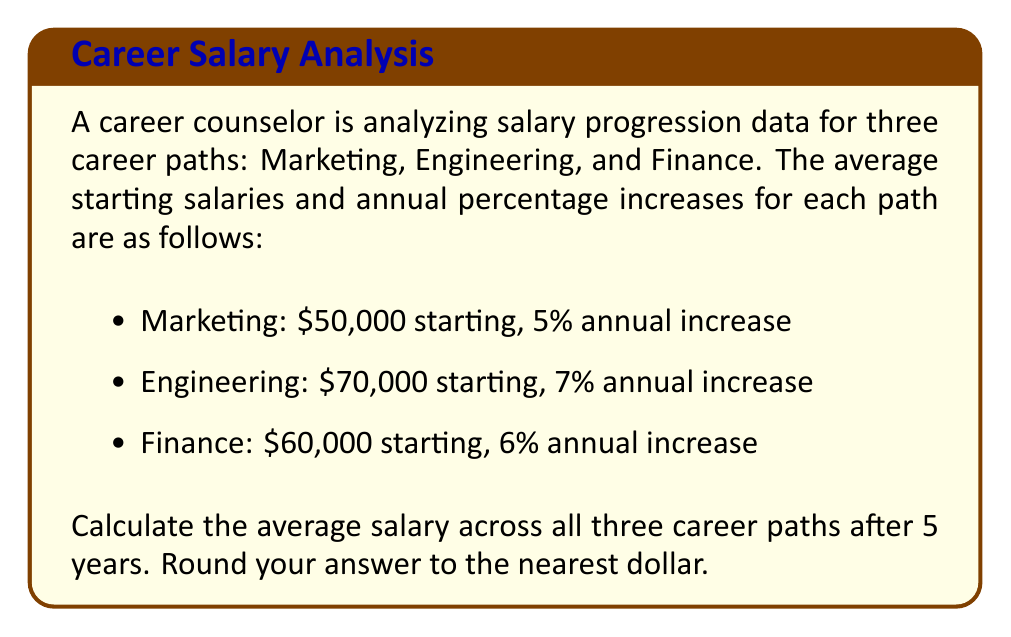Can you answer this question? Let's approach this step-by-step:

1) First, we need to calculate the salary for each career path after 5 years.

2) For Marketing:
   $50,000 * (1.05)^5 = $50,000 * 1.2762815625 = $63,814.08

3) For Engineering:
   $70,000 * (1.07)^5 = $70,000 * 1.4025517325 = $98,178.62

4) For Finance:
   $60,000 * (1.06)^5 = $60,000 * 1.3382256 = $80,293.54

5) Now we have the salaries after 5 years:
   Marketing: $63,814.08
   Engineering: $98,178.62
   Finance: $80,293.54

6) To find the average, we sum these salaries and divide by 3:

   $$\frac{63,814.08 + 98,178.62 + 80,293.54}{3} = \frac{242,286.24}{3} = 80,762.08$$

7) Rounding to the nearest dollar gives us $80,762.
Answer: $80,762 